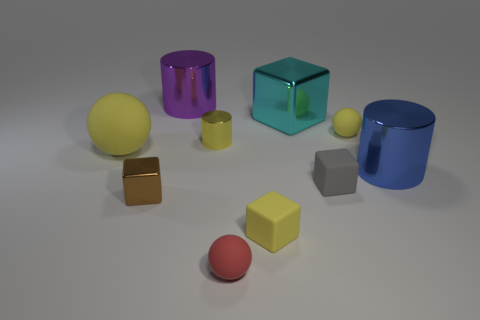Subtract all yellow spheres. How many were subtracted if there are1yellow spheres left? 1 Subtract 1 cubes. How many cubes are left? 3 Subtract all blocks. How many objects are left? 6 Subtract all small brown cubes. Subtract all cyan metal blocks. How many objects are left? 8 Add 4 yellow matte balls. How many yellow matte balls are left? 6 Add 1 tiny red rubber objects. How many tiny red rubber objects exist? 2 Subtract 1 gray blocks. How many objects are left? 9 